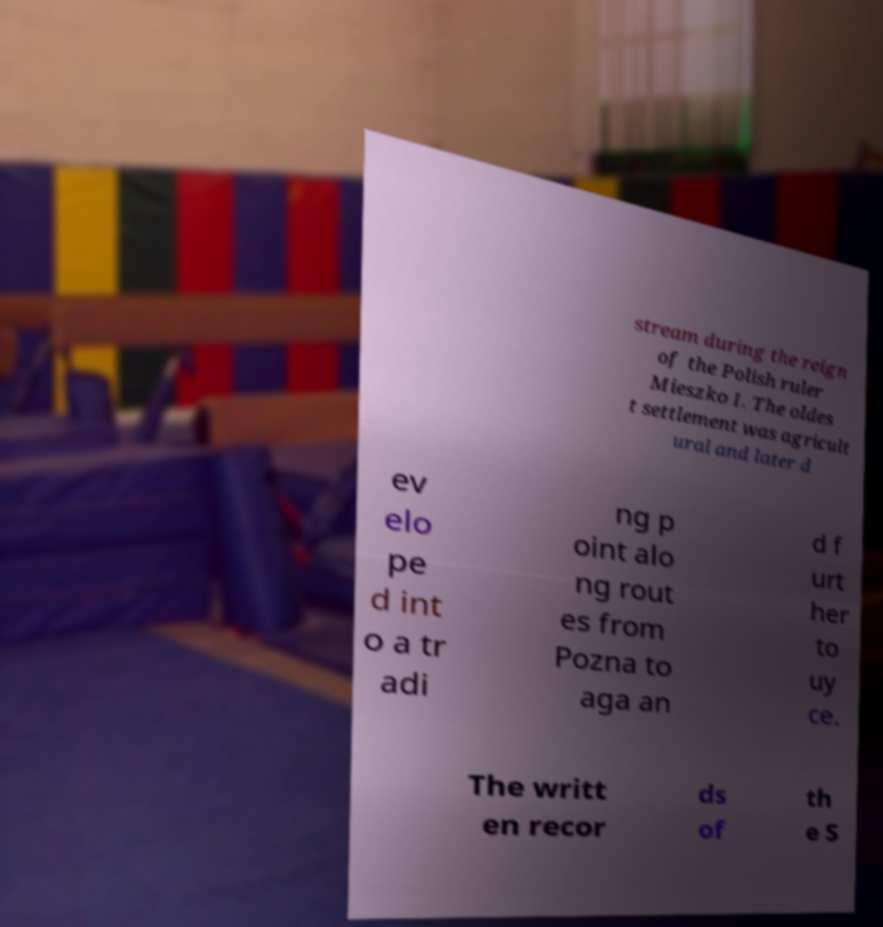Can you read and provide the text displayed in the image?This photo seems to have some interesting text. Can you extract and type it out for me? stream during the reign of the Polish ruler Mieszko I. The oldes t settlement was agricult ural and later d ev elo pe d int o a tr adi ng p oint alo ng rout es from Pozna to aga an d f urt her to uy ce. The writt en recor ds of th e S 